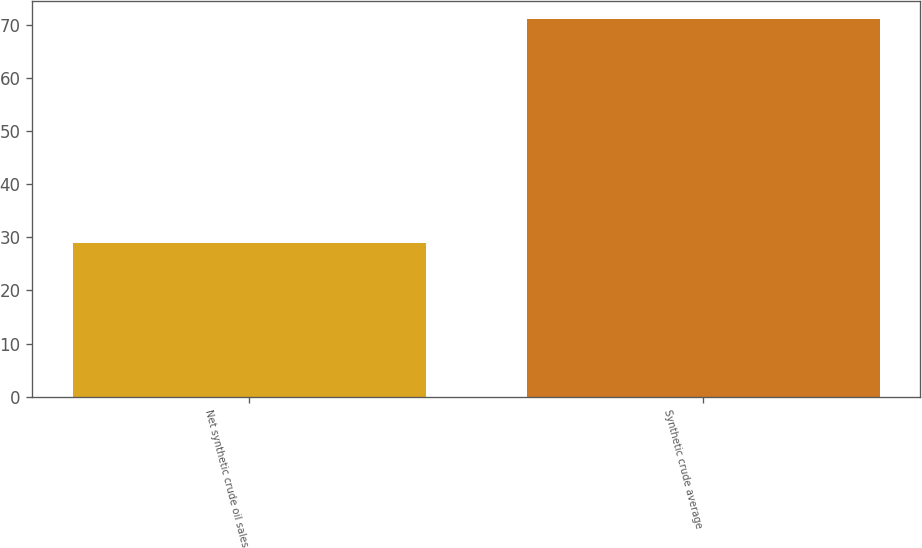Convert chart. <chart><loc_0><loc_0><loc_500><loc_500><bar_chart><fcel>Net synthetic crude oil sales<fcel>Synthetic crude average<nl><fcel>29<fcel>71.06<nl></chart> 